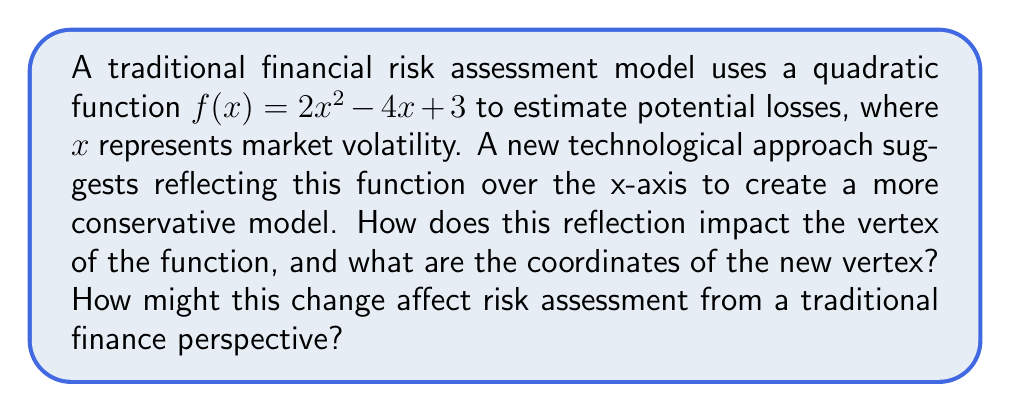Teach me how to tackle this problem. To solve this problem, we'll follow these steps:

1) First, let's recall that reflecting a function over the x-axis is achieved by negating the function: $g(x) = -f(x)$. So our new function is:

   $g(x) = -(2x^2 - 4x + 3) = -2x^2 + 4x - 3$

2) To find the vertex of a quadratic function in the form $ax^2 + bx + c$, we use the formula:

   $x = -\frac{b}{2a}$

3) For our original function $f(x) = 2x^2 - 4x + 3$:
   $a = 2$, $b = -4$

   $x = -\frac{(-4)}{2(2)} = \frac{4}{4} = 1$

4) To find the y-coordinate, we substitute this x-value back into the original function:

   $f(1) = 2(1)^2 - 4(1) + 3 = 2 - 4 + 3 = 1$

   So the vertex of the original function is (1, 1).

5) For our reflected function $g(x) = -2x^2 + 4x - 3$:
   The x-coordinate of the vertex remains the same, as reflection over the x-axis only affects the y-values.

   $x = 1$

6) To find the new y-coordinate, we use the new function $g(x)$:

   $g(1) = -2(1)^2 + 4(1) - 3 = -2 + 4 - 3 = -1$

7) Therefore, the new vertex is (1, -1).

From a traditional finance perspective, this change would make the risk assessment model more conservative. The original model had its vertex (lowest point) above the x-axis, suggesting positive returns even at the optimal volatility. The reflected model has its vertex (now the highest point) below the x-axis, suggesting that all volatility levels result in some degree of loss. This aligns with a more cautious, traditional approach to financial risk assessment.
Answer: The reflection changes the vertex from (1, 1) to (1, -1), making the risk assessment model more conservative by suggesting potential losses at all volatility levels. 